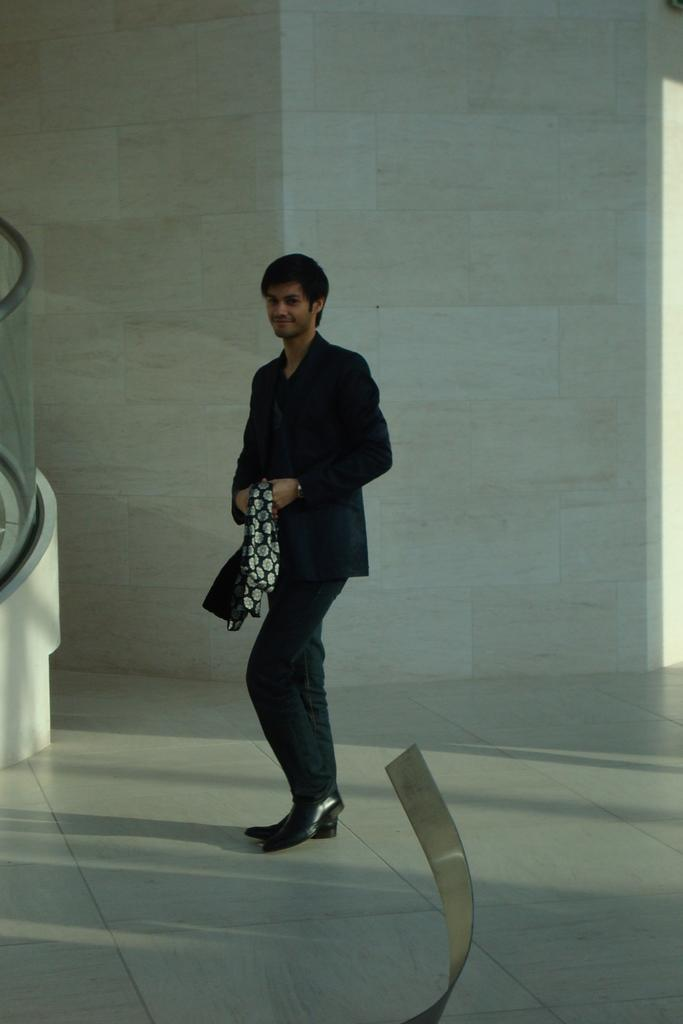What is the person in the image doing? There is a person standing in the image. What is the person wearing? The person is wearing a black dress. What is the person holding in the image? The person is holding something. What can be seen in the background of the image? There is a white color wall in the background of the image. What type of pencil can be seen in the person's hand in the image? There is no pencil visible in the person's hand in the image. What error is the person correcting in the image? There is no indication of an error or correction in the image. 